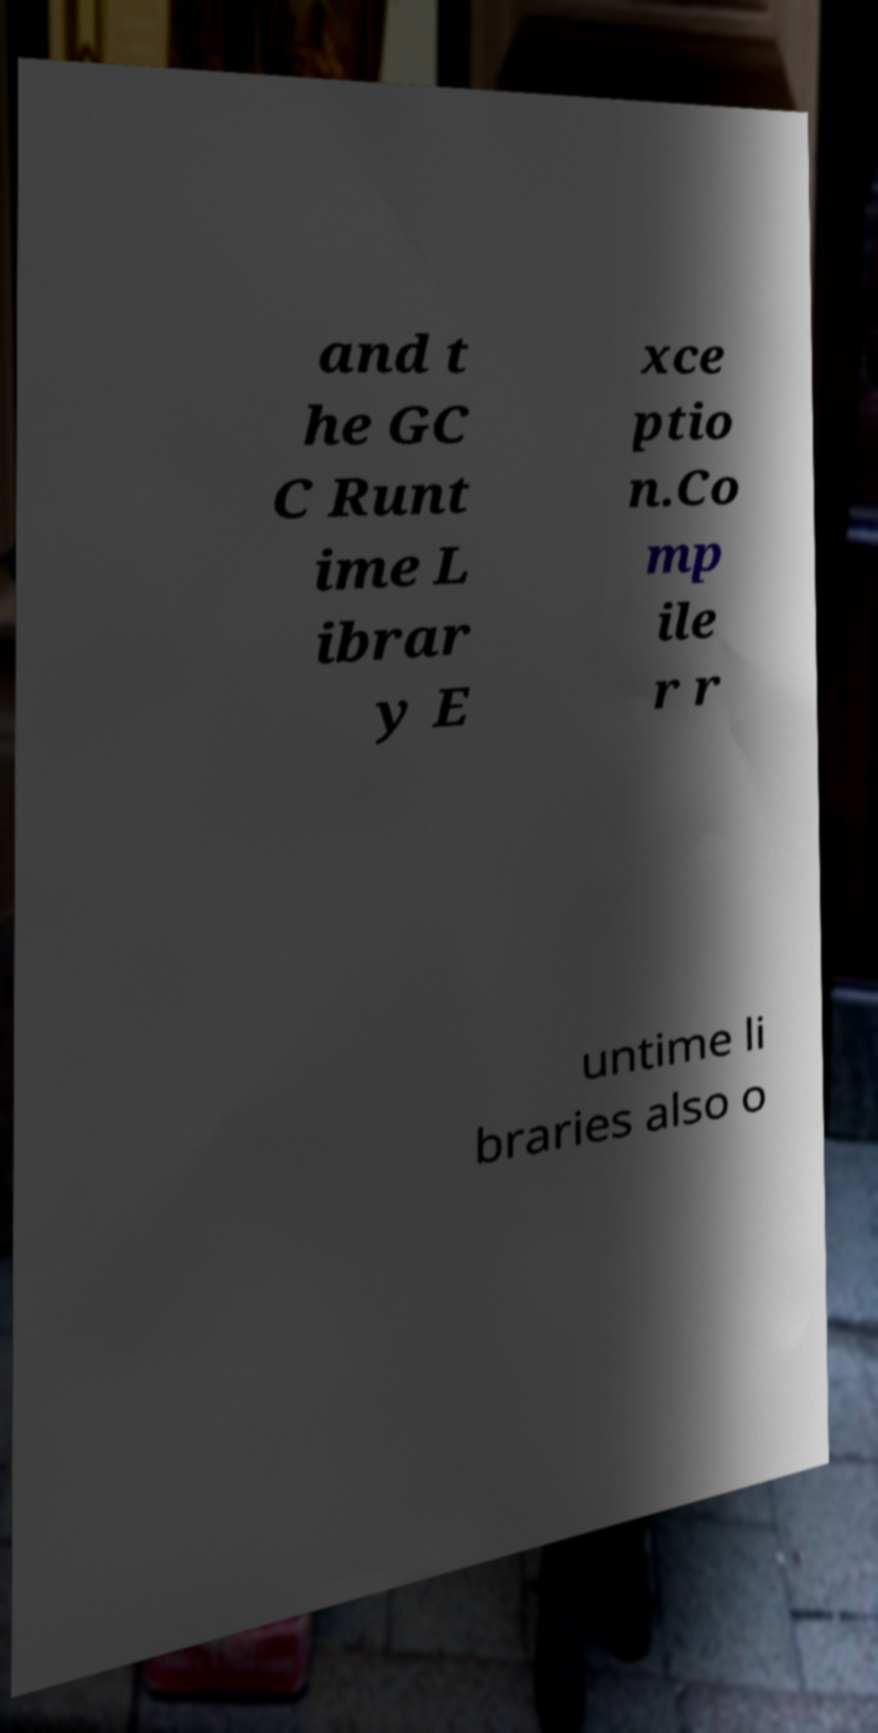Please identify and transcribe the text found in this image. and t he GC C Runt ime L ibrar y E xce ptio n.Co mp ile r r untime li braries also o 